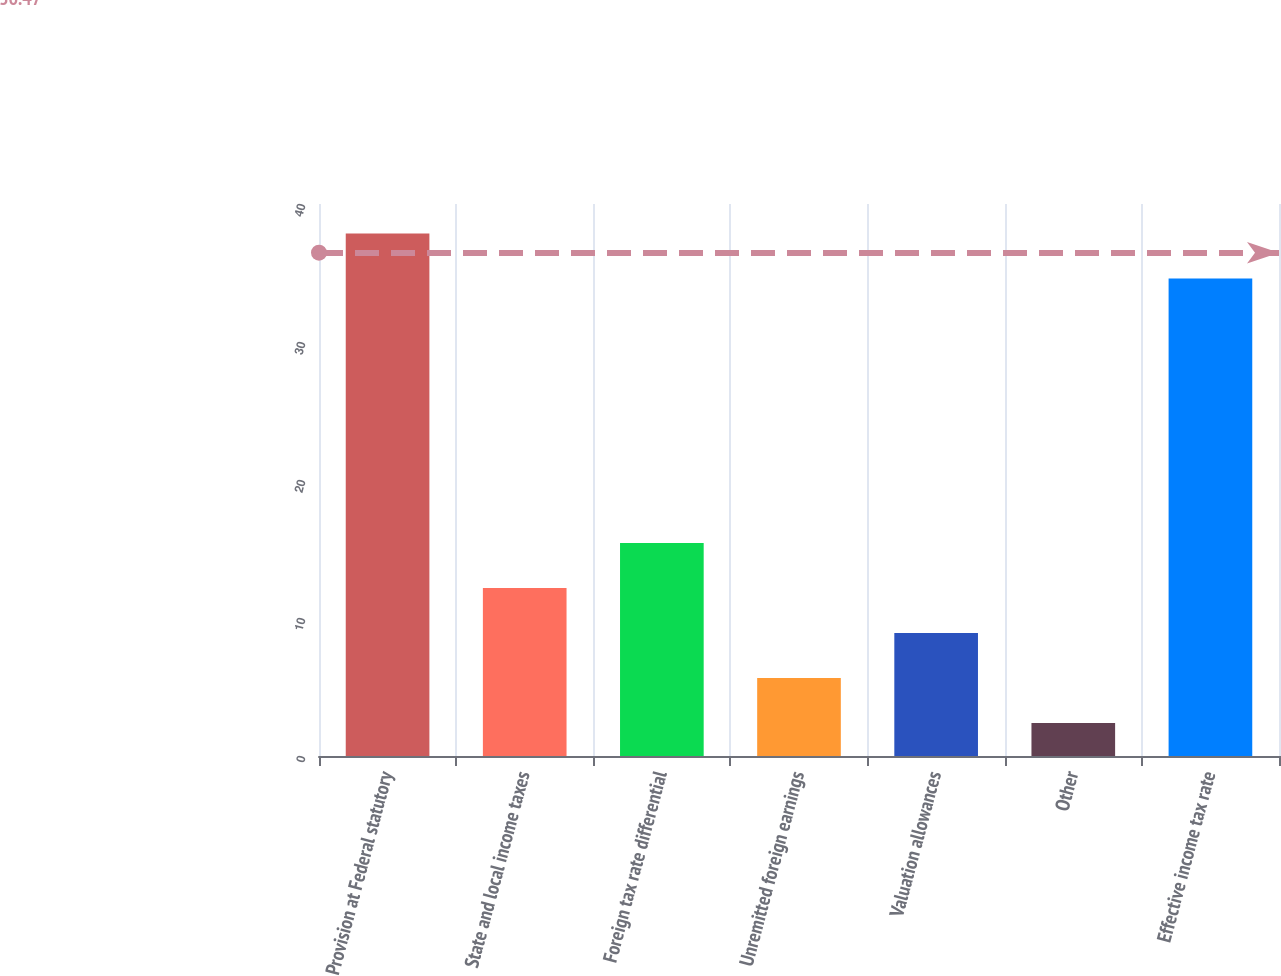<chart> <loc_0><loc_0><loc_500><loc_500><bar_chart><fcel>Provision at Federal statutory<fcel>State and local income taxes<fcel>Foreign tax rate differential<fcel>Unremitted foreign earnings<fcel>Valuation allowances<fcel>Other<fcel>Effective income tax rate<nl><fcel>37.86<fcel>12.18<fcel>15.44<fcel>5.66<fcel>8.92<fcel>2.4<fcel>34.6<nl></chart> 